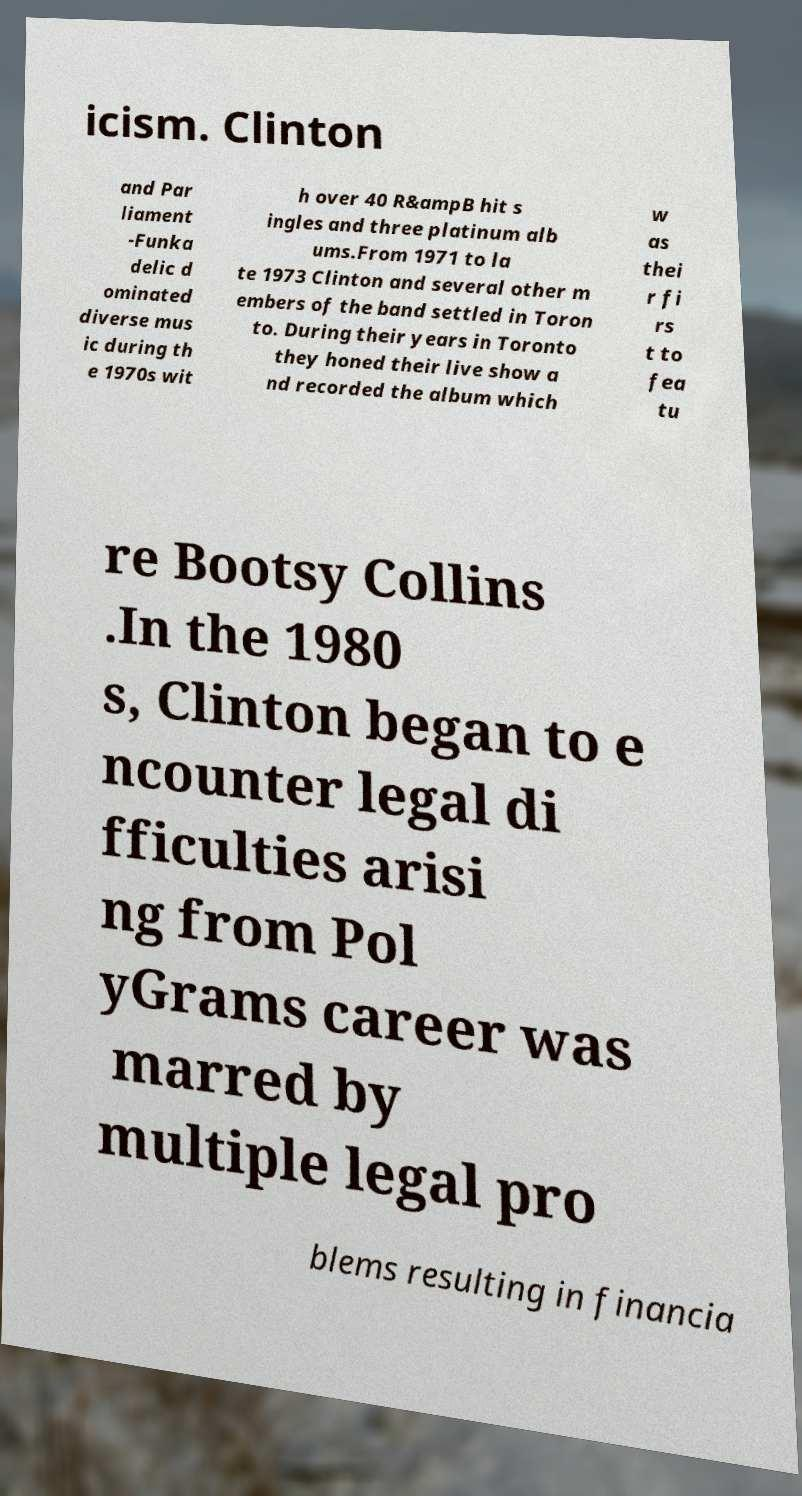I need the written content from this picture converted into text. Can you do that? icism. Clinton and Par liament -Funka delic d ominated diverse mus ic during th e 1970s wit h over 40 R&ampB hit s ingles and three platinum alb ums.From 1971 to la te 1973 Clinton and several other m embers of the band settled in Toron to. During their years in Toronto they honed their live show a nd recorded the album which w as thei r fi rs t to fea tu re Bootsy Collins .In the 1980 s, Clinton began to e ncounter legal di fficulties arisi ng from Pol yGrams career was marred by multiple legal pro blems resulting in financia 